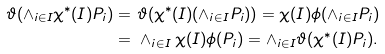Convert formula to latex. <formula><loc_0><loc_0><loc_500><loc_500>\vartheta ( \wedge _ { i \in I } \chi ^ { * } ( I ) P _ { i } ) = & \ \vartheta ( \chi ^ { * } ( I ) ( \wedge _ { i \in I } P _ { i } ) ) = \chi ( I ) \phi ( \wedge _ { i \in I } P _ { i } ) \\ = & \ \wedge _ { i \in I } \chi ( I ) \phi ( P _ { i } ) = \wedge _ { i \in I } \vartheta ( \chi ^ { * } ( I ) P _ { i } ) .</formula> 